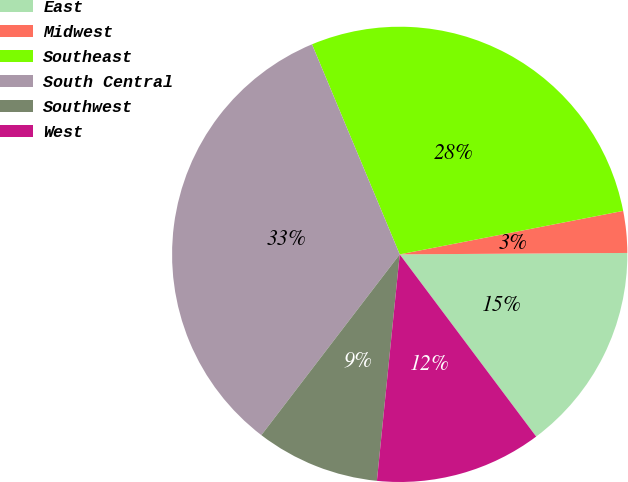<chart> <loc_0><loc_0><loc_500><loc_500><pie_chart><fcel>East<fcel>Midwest<fcel>Southeast<fcel>South Central<fcel>Southwest<fcel>West<nl><fcel>14.87%<fcel>2.96%<fcel>28.24%<fcel>33.31%<fcel>8.8%<fcel>11.83%<nl></chart> 